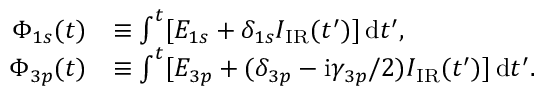<formula> <loc_0><loc_0><loc_500><loc_500>\begin{array} { r l } { \Phi _ { 1 s } ( t ) } & { \equiv \int ^ { t } [ E _ { 1 s } + \delta _ { 1 s } I _ { I R } ( t ^ { \prime } ) ] \, \mathrm d t ^ { \prime } , } \\ { \Phi _ { 3 p } ( t ) } & { \equiv \int ^ { t } [ E _ { 3 p } + ( \delta _ { 3 p } - \mathrm i \gamma _ { 3 p } / 2 ) I _ { I R } ( t ^ { \prime } ) ] \, \mathrm d t ^ { \prime } . } \end{array}</formula> 